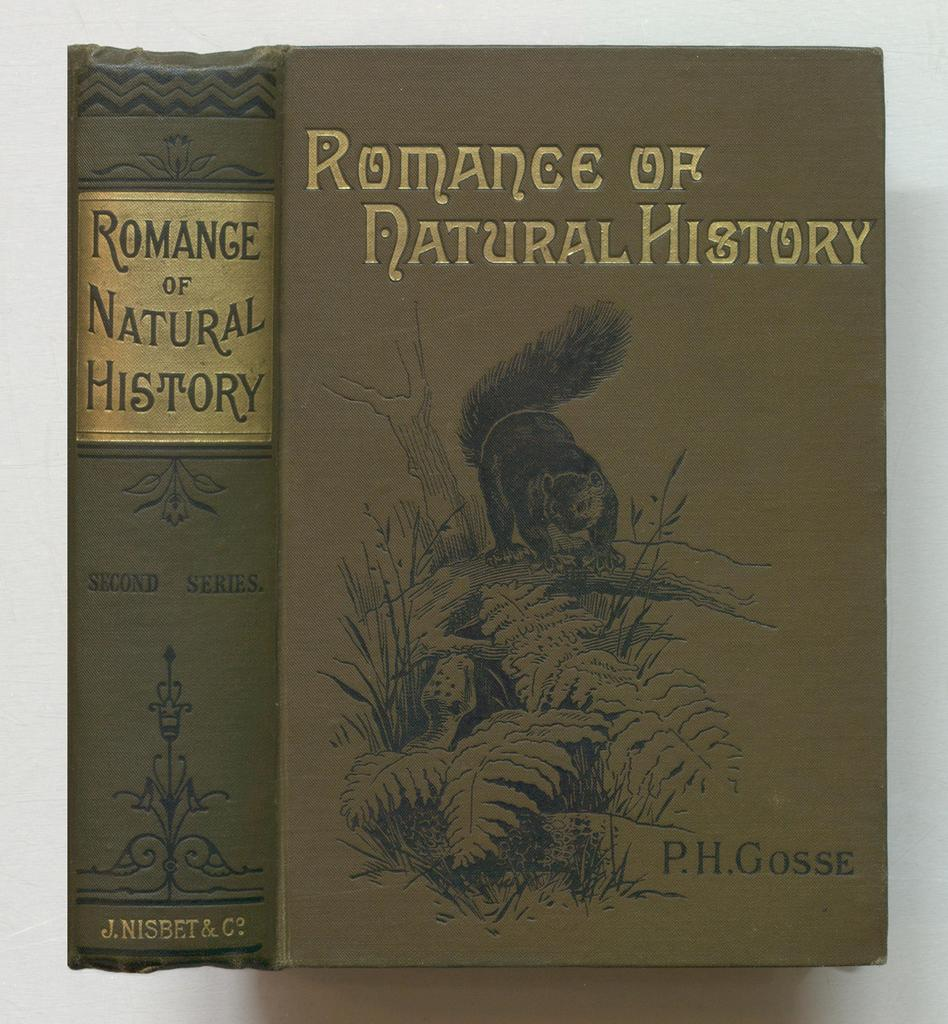Provide a one-sentence caption for the provided image. A book written by P.H. Gosse concerns the Romance of Natural History. 